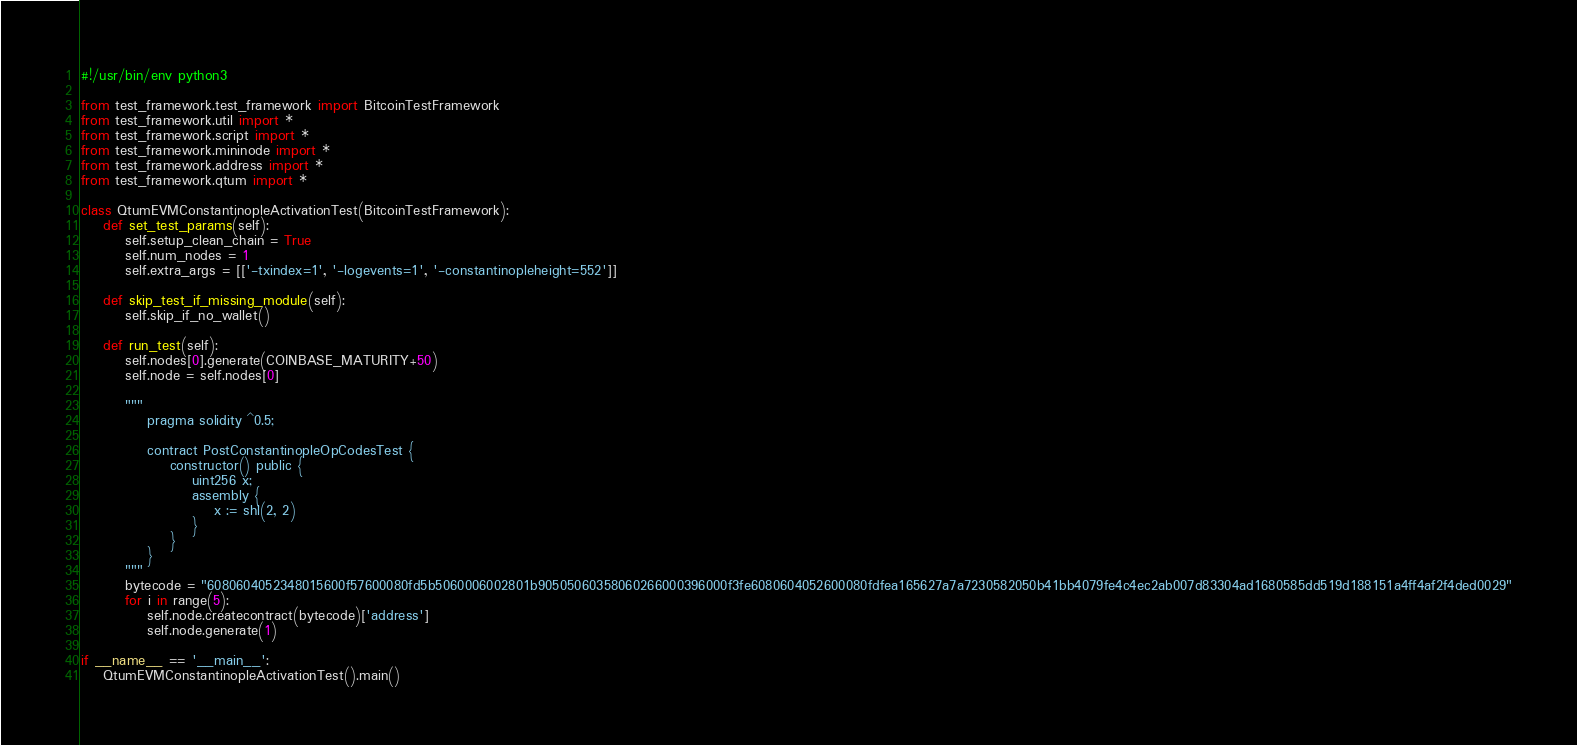<code> <loc_0><loc_0><loc_500><loc_500><_Python_>#!/usr/bin/env python3

from test_framework.test_framework import BitcoinTestFramework
from test_framework.util import *
from test_framework.script import *
from test_framework.mininode import *
from test_framework.address import *
from test_framework.qtum import *

class QtumEVMConstantinopleActivationTest(BitcoinTestFramework):
    def set_test_params(self):
        self.setup_clean_chain = True
        self.num_nodes = 1
        self.extra_args = [['-txindex=1', '-logevents=1', '-constantinopleheight=552']]

    def skip_test_if_missing_module(self):
        self.skip_if_no_wallet()

    def run_test(self):
        self.nodes[0].generate(COINBASE_MATURITY+50)
        self.node = self.nodes[0]

        """
            pragma solidity ^0.5;

            contract PostConstantinopleOpCodesTest {
                constructor() public {
                    uint256 x;
                    assembly {
                        x := shl(2, 2)
                    }
                }
            }
        """
        bytecode = "6080604052348015600f57600080fd5b5060006002801b90505060358060266000396000f3fe6080604052600080fdfea165627a7a7230582050b41bb4079fe4c4ec2ab007d83304ad1680585dd519d188151a4ff4af2f4ded0029"
        for i in range(5):
            self.node.createcontract(bytecode)['address']
            self.node.generate(1)

if __name__ == '__main__':
    QtumEVMConstantinopleActivationTest().main()
</code> 